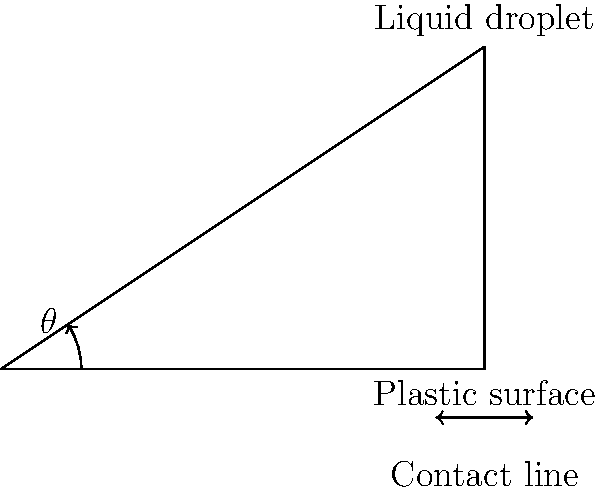In the diagram, a liquid droplet is resting on a plastic surface. The contact angle $\theta$ is measured to assess the hydrophobicity of the surface. If the contact angle is found to be 33.69°, what can be concluded about the surface's hydrophobicity? To determine the hydrophobicity of the surface based on the contact angle, we need to follow these steps:

1. Understand the relationship between contact angle and hydrophobicity:
   - Contact angle $\theta < 90°$: hydrophilic surface
   - Contact angle $\theta > 90°$: hydrophobic surface
   - Contact angle $\theta > 150°$: superhydrophobic surface

2. Analyze the given contact angle:
   $\theta = 33.69°$

3. Compare the given angle to the hydrophobicity thresholds:
   $33.69° < 90°$

4. Interpret the result:
   Since the contact angle is less than 90°, the surface is hydrophilic.

5. Understand the implications:
   - A hydrophilic surface has a higher surface energy.
   - It tends to attract water and other polar molecules.
   - The liquid droplet will spread out more on the surface.

Therefore, based on the measured contact angle of 33.69°, we can conclude that the plastic surface is hydrophilic.
Answer: Hydrophilic 